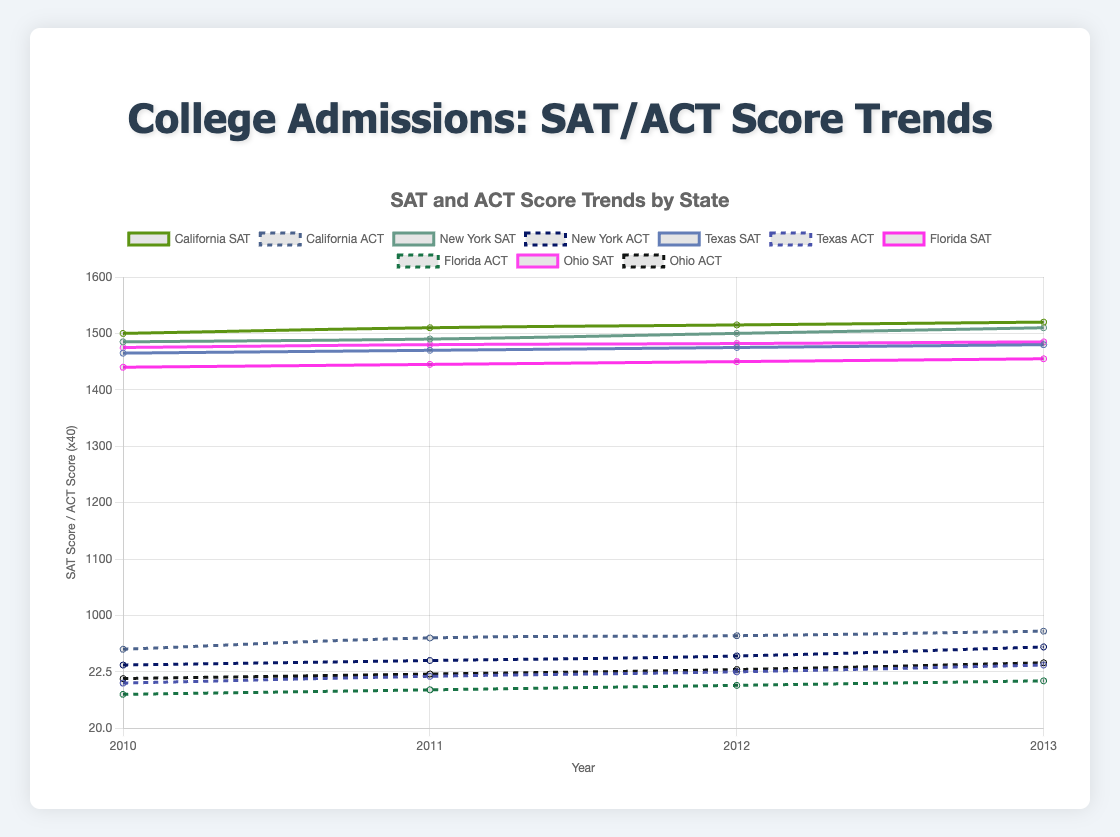What's the trend in SAT scores for California from 2010 to 2013? The SAT scores for California increase every year from 2010 to 2013. In 2010, the score is 1500, it rises to 1510 in 2011, 1515 in 2012, and 1520 in 2013. The data shows a consistent upward trend over the years.
Answer: Upward trend Which state has the highest ACT score in 2013? To find this, we look at the ACT scores for each state in 2013. California has 24.3, New York has 23.6, Texas has 22.8, Florida has 22.1, and Ohio has 22.9. Clearly, California has the highest ACT score in 2013.
Answer: California Comparing SAT scores, which state showed the largest increase from 2010 to 2013? We need to calculate the difference in SAT scores from 2010 to 2013 for each state. California's increase is (1520-1500)=20, New York's increase is (1510-1485)=25, Texas's increase is (1480-1465)=15, Florida's increase is (1455-1440)=15, and Ohio's increase is (1485-1475)=10. New York shows the largest increase.
Answer: New York What is the combined SAT score trend for New York from 2010 to 2013? Examining the SAT scores for New York from 2010 to 2013, we see 1485 in 2010, 1490 in 2011, 1500 in 2012, and 1510 in 2013. Each year, the score increases by 5-10 points, showing a steady upward trend.
Answer: Upward trend Which state has the lowest SAT score in 2010? Looking at the SAT scores for 2010, California has 1500, New York has 1485, Texas has 1465, Florida has 1440, and Ohio has 1475. Florida has the lowest SAT score in 2010.
Answer: Florida What is the average SAT score for Texas across the years 2010 to 2013? To find the average, sum up the SAT scores for Texas from 2010 to 2013 and divide by the number of years: (1465 + 1470 + 1475 + 1480)/4 = 1472.5. The average SAT score for Texas is 1472.5.
Answer: 1472.5 How does the trend in ACT scores for Florida compare to Texas from 2010 to 2013? Florida's ACT scores from 2010 to 2013 are 21.5, 21.7, 21.9, and 22.1, which show a gradual increase. Texas's ACT scores are 22.0, 22.3, 22.5, and 22.8, also showing a gradual increase. Both states show increasing trends in ACT scores over the same period.
Answer: Similar upward trend What was the difference between the average SAT scores of Ohio and Florida in 2012? In 2012, Ohio's average SAT score is 1482, and Florida's is 1450. The difference is 1482 - 1450 = 32. The difference in SAT scores between Ohio and Florida in 2012 is 32 points.
Answer: 32 Comparing the trends, which state shows the most significant overall improvement in both SAT and ACT scores from 2010 to 2013? By comparing the score increases, California's SAT scores increased by 20 points (1500 to 1520) and ACT scores by 0.8 points (23.5 to 24.3). New York's SAT scores increased by 25 points and ACT by 0.8 points. Texas's SAT scores increased by 15 points and ACT by 0.8 points. Florida's SAT scores increased by 15 points and ACT by 0.6 points. Ohio's SAT increased by 10 points and ACT by 0.7 points. New York shows the most significant overall improvement.
Answer: New York 